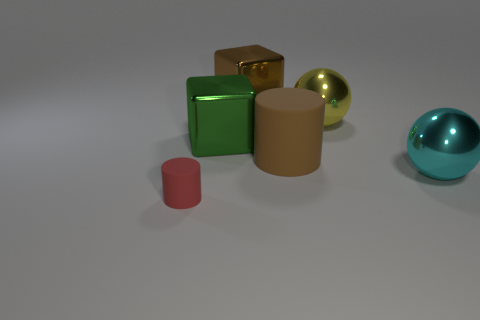Add 2 big blue rubber spheres. How many objects exist? 8 Subtract all cylinders. How many objects are left? 4 Subtract 0 green spheres. How many objects are left? 6 Subtract all big brown shiny cylinders. Subtract all big yellow spheres. How many objects are left? 5 Add 2 green shiny cubes. How many green shiny cubes are left? 3 Add 2 tiny red matte objects. How many tiny red matte objects exist? 3 